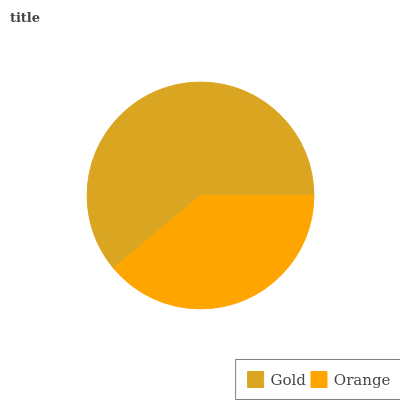Is Orange the minimum?
Answer yes or no. Yes. Is Gold the maximum?
Answer yes or no. Yes. Is Orange the maximum?
Answer yes or no. No. Is Gold greater than Orange?
Answer yes or no. Yes. Is Orange less than Gold?
Answer yes or no. Yes. Is Orange greater than Gold?
Answer yes or no. No. Is Gold less than Orange?
Answer yes or no. No. Is Gold the high median?
Answer yes or no. Yes. Is Orange the low median?
Answer yes or no. Yes. Is Orange the high median?
Answer yes or no. No. Is Gold the low median?
Answer yes or no. No. 